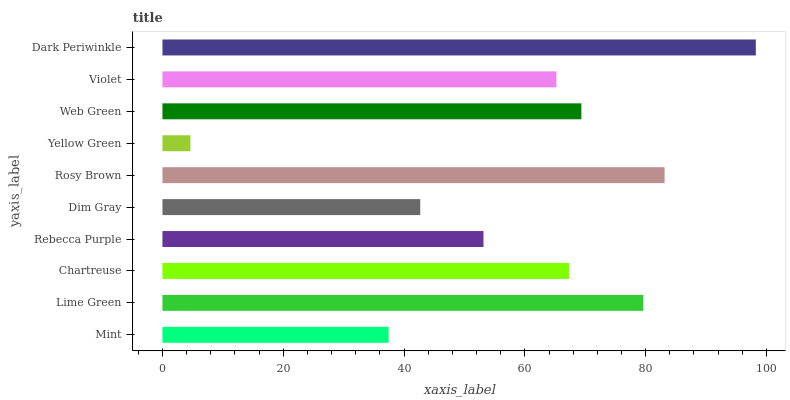Is Yellow Green the minimum?
Answer yes or no. Yes. Is Dark Periwinkle the maximum?
Answer yes or no. Yes. Is Lime Green the minimum?
Answer yes or no. No. Is Lime Green the maximum?
Answer yes or no. No. Is Lime Green greater than Mint?
Answer yes or no. Yes. Is Mint less than Lime Green?
Answer yes or no. Yes. Is Mint greater than Lime Green?
Answer yes or no. No. Is Lime Green less than Mint?
Answer yes or no. No. Is Chartreuse the high median?
Answer yes or no. Yes. Is Violet the low median?
Answer yes or no. Yes. Is Rosy Brown the high median?
Answer yes or no. No. Is Rosy Brown the low median?
Answer yes or no. No. 